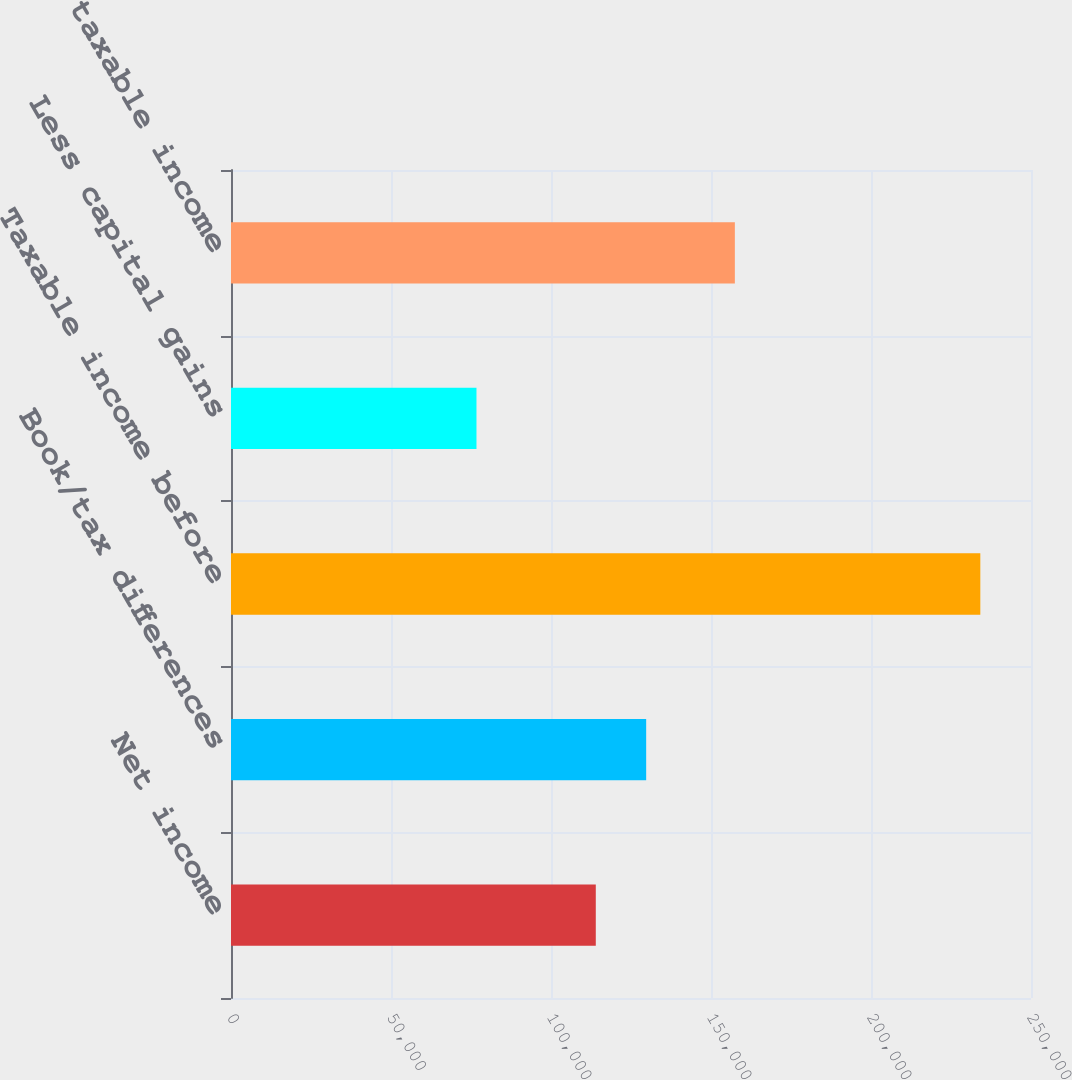<chart> <loc_0><loc_0><loc_500><loc_500><bar_chart><fcel>Net income<fcel>Book/tax differences<fcel>Taxable income before<fcel>Less capital gains<fcel>Adjusted taxable income<nl><fcel>113996<fcel>129742<fcel>234164<fcel>76709<fcel>157455<nl></chart> 